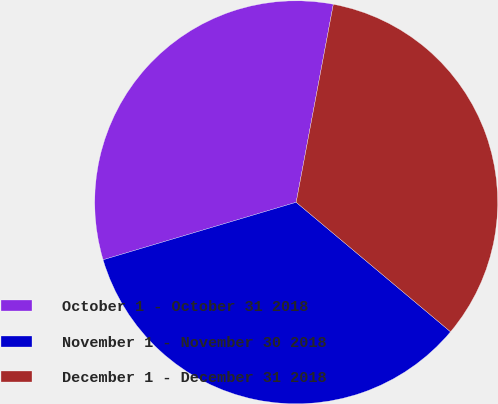Convert chart. <chart><loc_0><loc_0><loc_500><loc_500><pie_chart><fcel>October 1 - October 31 2018<fcel>November 1 - November 30 2018<fcel>December 1 - December 31 2018<nl><fcel>32.56%<fcel>34.29%<fcel>33.16%<nl></chart> 